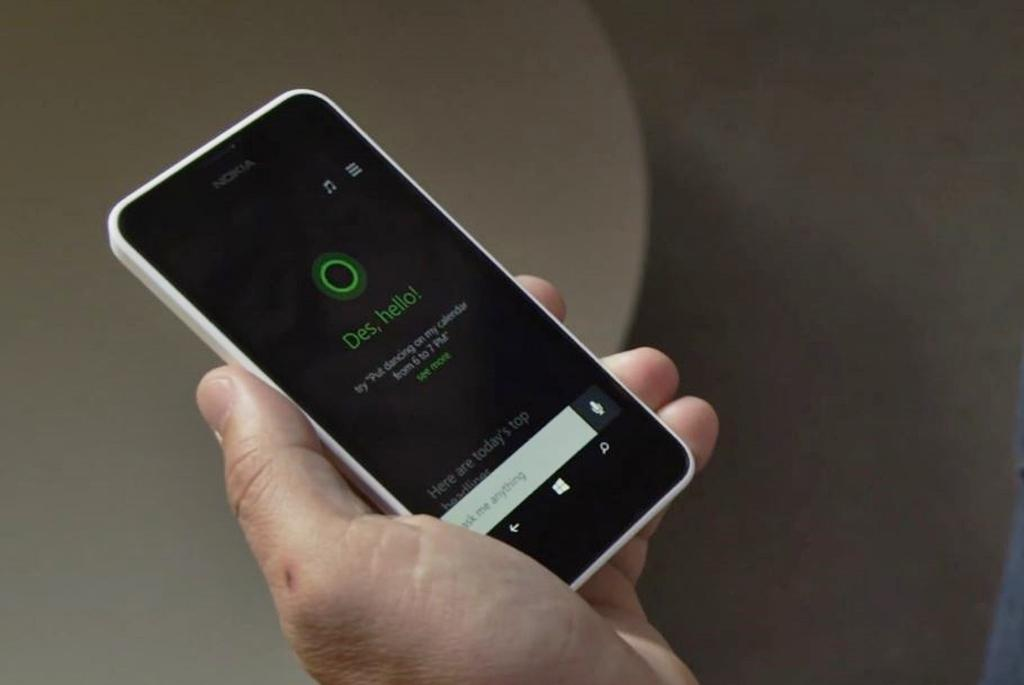<image>
Present a compact description of the photo's key features. A phone displays the text, "des, hello!" on it. 